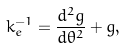Convert formula to latex. <formula><loc_0><loc_0><loc_500><loc_500>k _ { e } ^ { - 1 } = \frac { d ^ { 2 } g } { d \theta ^ { 2 } } + g ,</formula> 